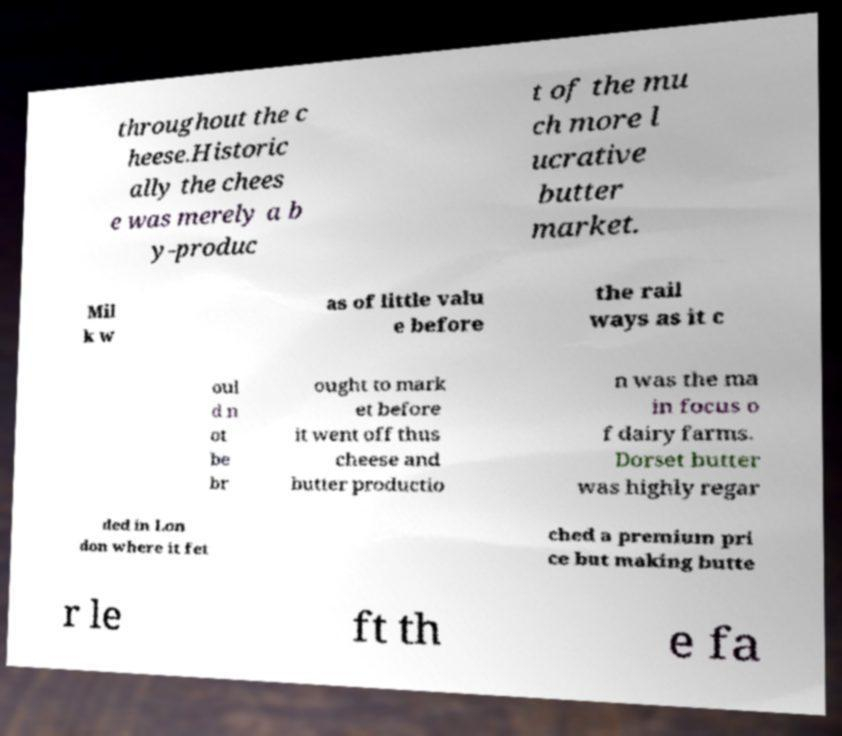What messages or text are displayed in this image? I need them in a readable, typed format. throughout the c heese.Historic ally the chees e was merely a b y-produc t of the mu ch more l ucrative butter market. Mil k w as of little valu e before the rail ways as it c oul d n ot be br ought to mark et before it went off thus cheese and butter productio n was the ma in focus o f dairy farms. Dorset butter was highly regar ded in Lon don where it fet ched a premium pri ce but making butte r le ft th e fa 